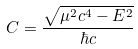<formula> <loc_0><loc_0><loc_500><loc_500>C = \frac { \sqrt { \mu ^ { 2 } c ^ { 4 } - E ^ { 2 } } } { \hbar { c } }</formula> 